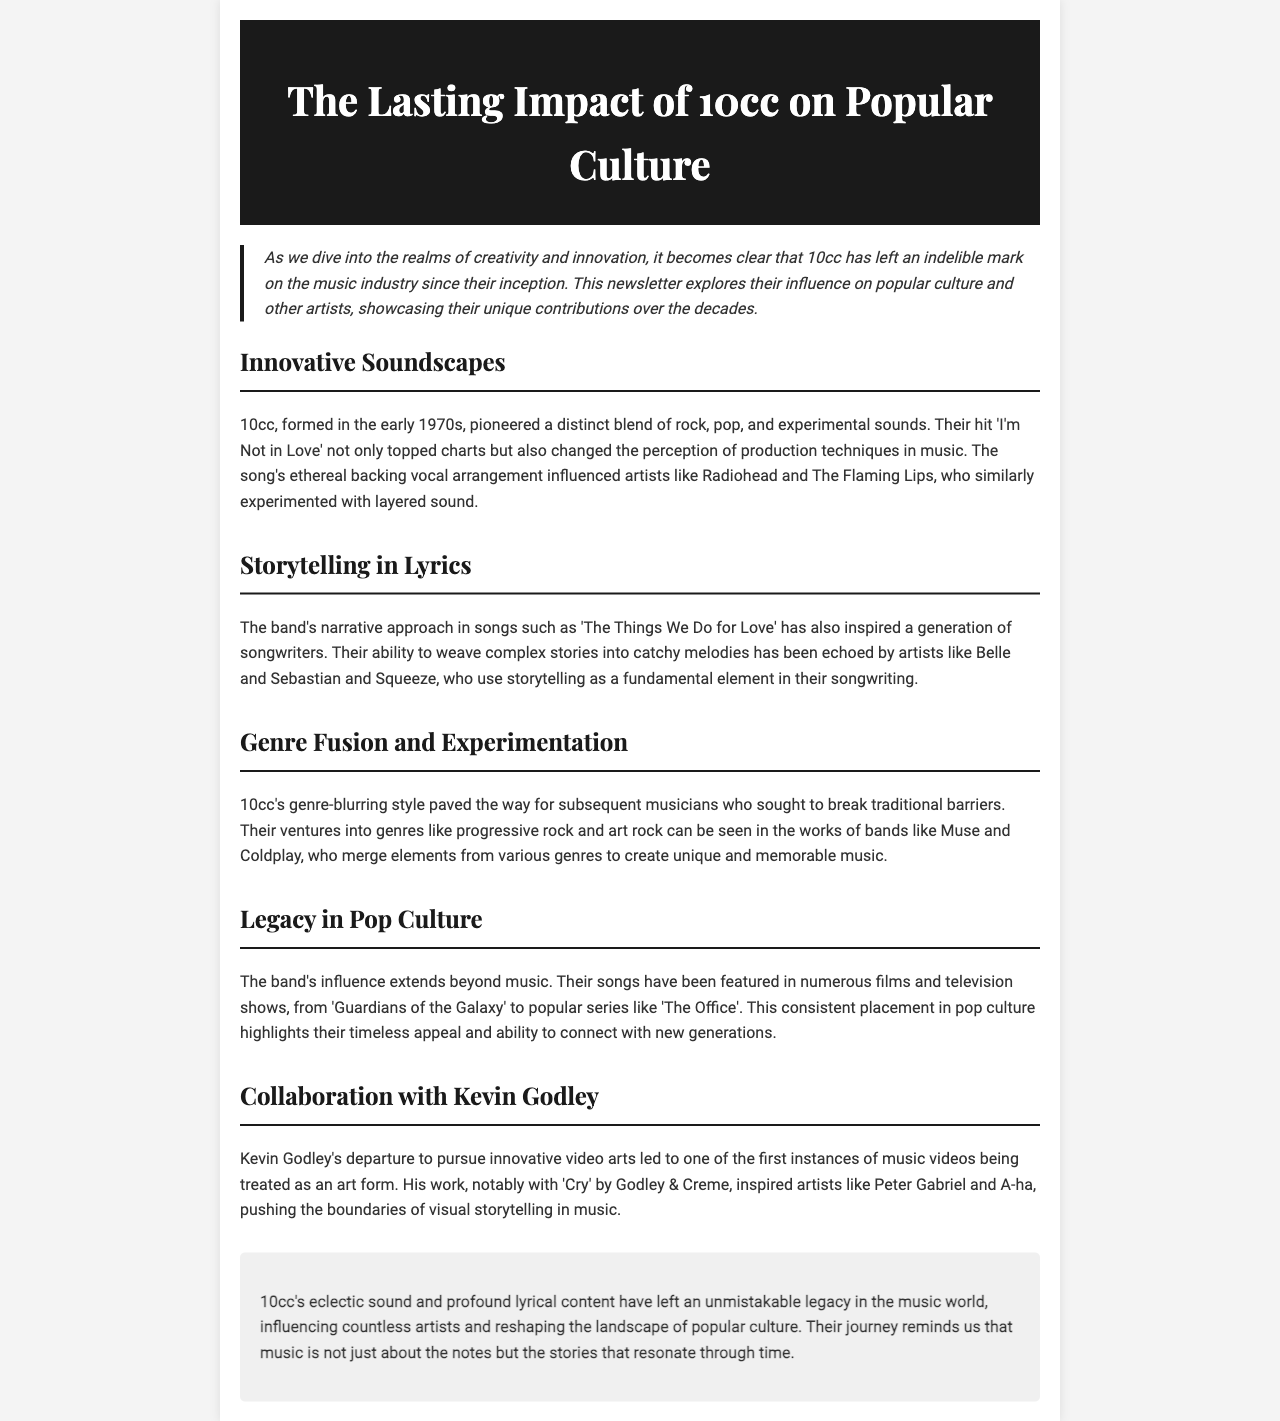What is the title of the newsletter? The title of the newsletter is stated prominently at the top of the document.
Answer: The Lasting Impact of 10cc on Popular Culture Who are the bands mentioned that were influenced by 10cc's production techniques? The document lists specific artists who were influenced, highlighting their names in the context of production.
Answer: Radiohead and The Flaming Lips What song by 10cc is noted for changing production perceptions? A specific song is noted in the document for its impact on music production techniques.
Answer: I'm Not in Love Which 10cc song is referred to for its storytelling approach? The document mentions a particular song to exemplify the band's narrative style in their music.
Answer: The Things We Do for Love What genre-blurring band mentioned in the document emerged after 10cc? The document highlights modern artists who have undertaken a similar genre-blurring style.
Answer: Muse Which music video director left to pursue innovative video arts? The newsletter specifically acknowledges an individual's contribution to the evolution of music videos.
Answer: Kevin Godley Name one film or TV show where 10cc's songs have been featured. The document provides examples of media where the band's music has appeared, indicating their cultural impact.
Answer: Guardians of the Galaxy What is one key element of 10cc's music that has influenced other artists? A specific characteristic of 10cc's music that has inspired musicians is addressed in the document.
Answer: Eclectic sound In what year was 10cc formed? The document provides information regarding the formation period of the band.
Answer: Early 1970s 